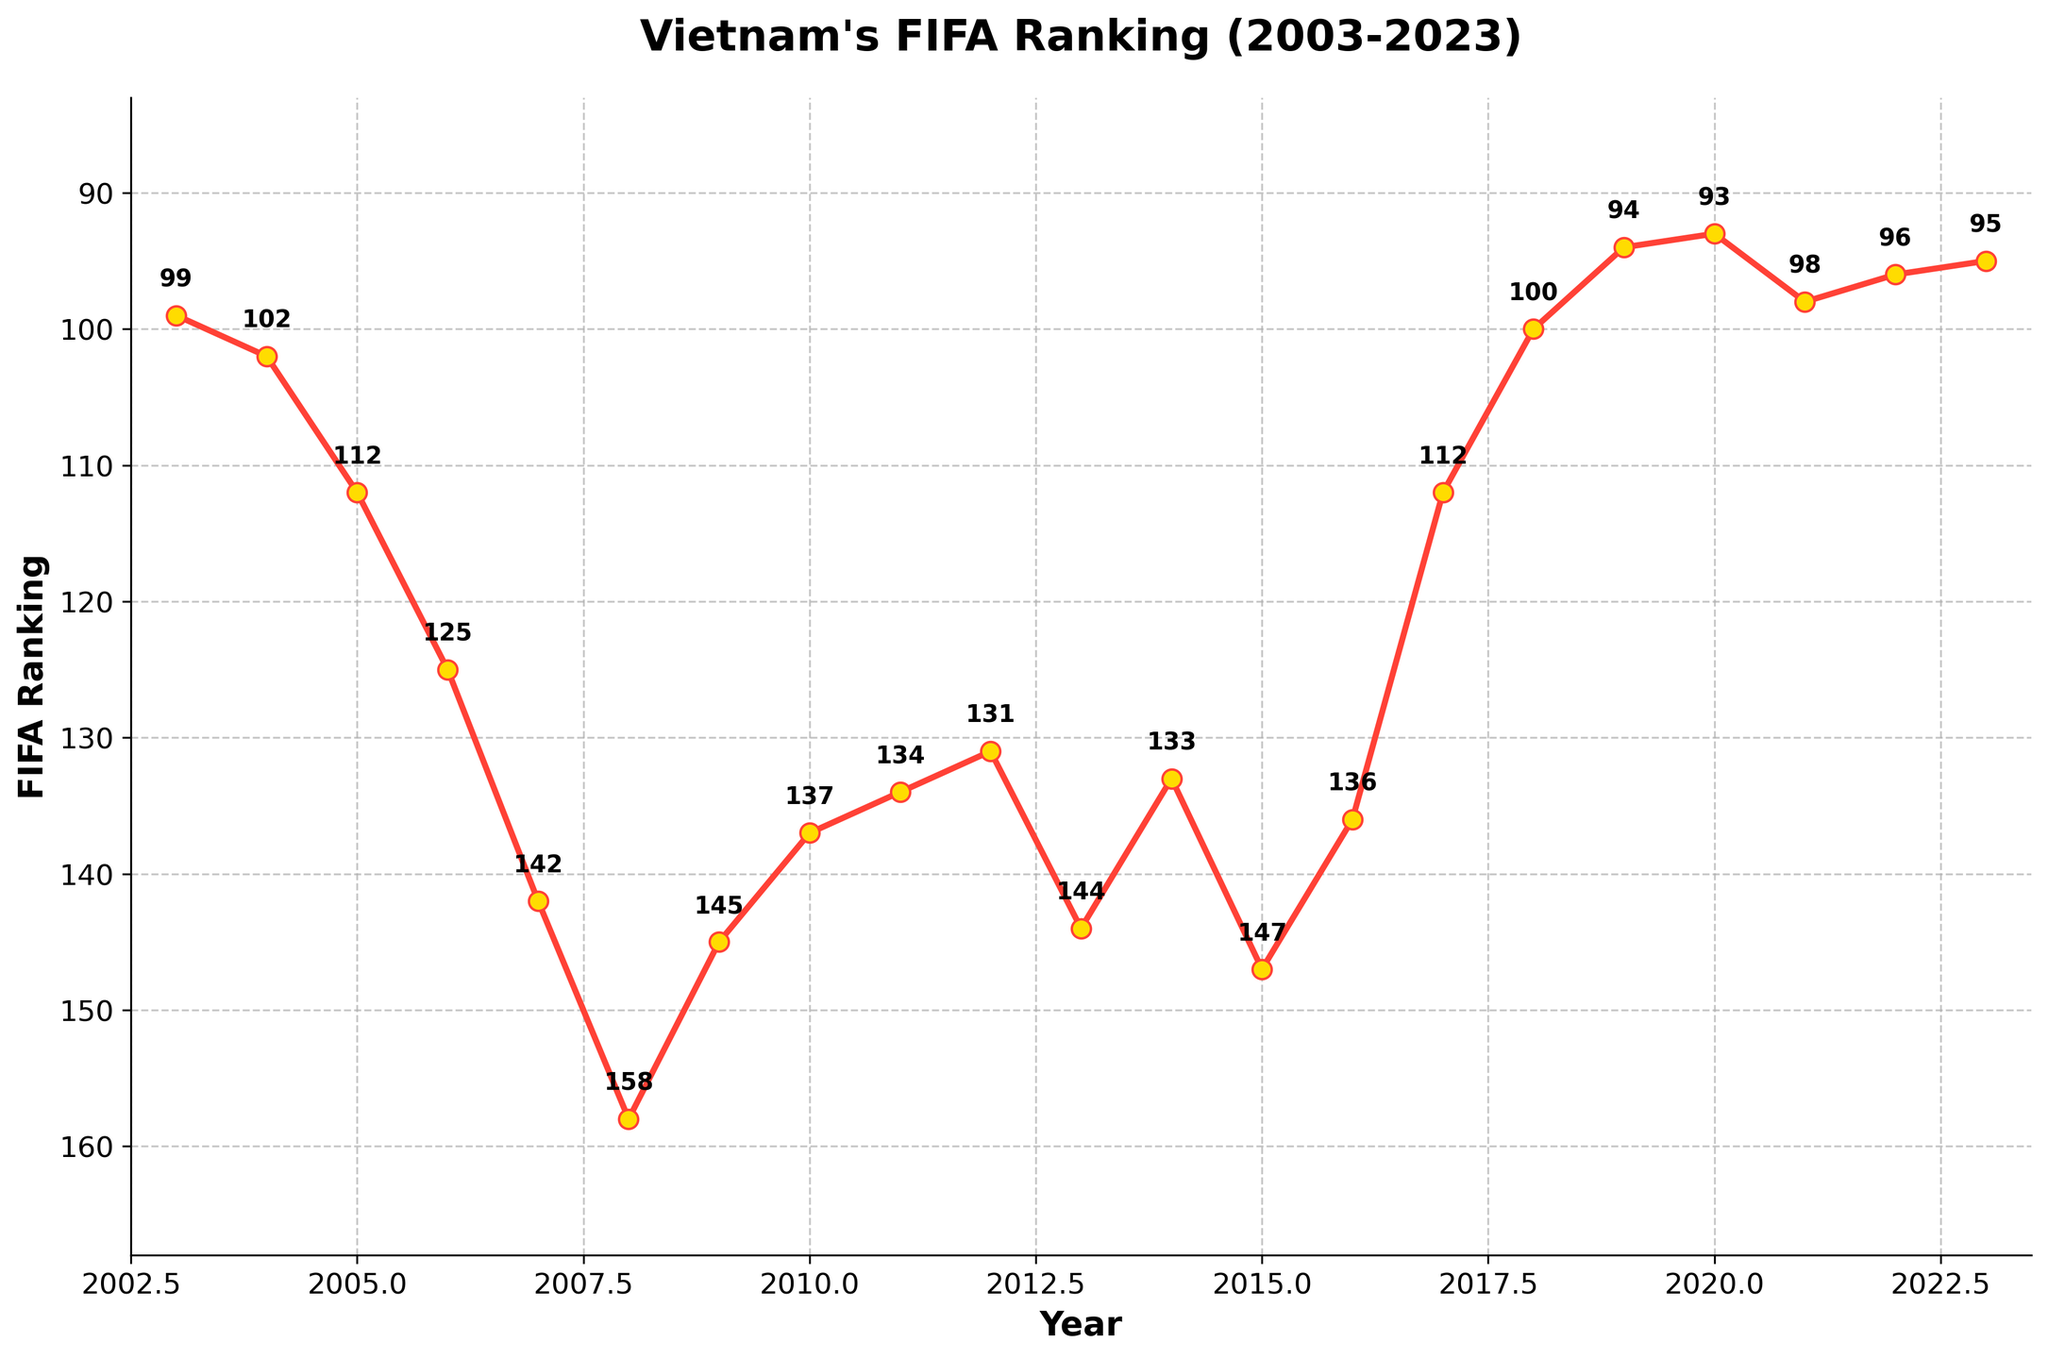What's the trend in Vietnam's FIFA ranking from 2003 to 2023? The graph shows that the FIFA ranking of Vietnam initially worsened from 2003 to 2008, reaching a peak at around 158, then improved gradually despite some fluctuations until 2023, reaching a low of 93 in 2020.
Answer: Generally improving trend Which year did Vietnam have the lowest FIFA ranking and what was the rank? By examining the graph, Vietnam's lowest FIFA ranking was in 2008, where they were ranked 158.
Answer: 2008, 158 Compare Vietnam's FIFA ranking in 2003 and 2023. Which year had a better ranking? The plot shows that in 2003, Vietnam's ranking was 99, and it improved to 95 by 2023. Hence, 2023 had a better ranking.
Answer: 2023 What was Vietnam's FIFA ranking change from 2007 to 2008? From the plot, in 2007, the ranking was 142 and in 2008 it worsened to 158. The change is 158 - 142 = 16. So, Vietnam's ranking worsened by 16 places.
Answer: Worsened by 16 What is the average FIFA ranking of Vietnam from 2003 to 2023? Add up the rankings from each year (99 + 102 + 112 + 125 + 142 + 158 + 145 + 137 + 134 + 131 + 144 + 133 + 147 + 136 + 112 + 100 + 94 + 93 + 98 + 96 + 95) and then divide by the number of years (21). Sum of rankings = 2544. The average is 2544 / 21 ≈ 121.1.
Answer: 121.1 How did Vietnam's FIFA ranking change from 2015 to 2017? In 2015, the ranking was 147, and by 2017, it improved to 112. The change is 147 - 112 = 35, so the ranking improved by 35 places.
Answer: Improved by 35 In which period did Vietnam see the most considerable improvement in their FIFA ranking? The plot shows that between 2015 and 2017, Vietnam's ranking improved significantly from 147 to 112.
Answer: 2015-2017 How many times did Vietnam's FIFA ranking improve consecutively over the years provided? By examining the plot, notable consecutive improvements are from 2008 to 2012, 2015 to 2018, and 2019 to 2020.
Answer: 3 times How does the FIFA ranking in 2020 compare with 2013? The ranking in 2020 was 93, while in 2013 it was 144. The ranking in 2020 is better.
Answer: 2020 is better What is the most common trend in Vietnam's FIFA ranking, improving or worsening? By analyzing the general trend apparent from the plot, the more frequent trend seems to be an improvement despite some fluctuations.
Answer: Improving 